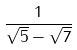<formula> <loc_0><loc_0><loc_500><loc_500>\frac { 1 } { \sqrt { 5 } - \sqrt { 7 } }</formula> 